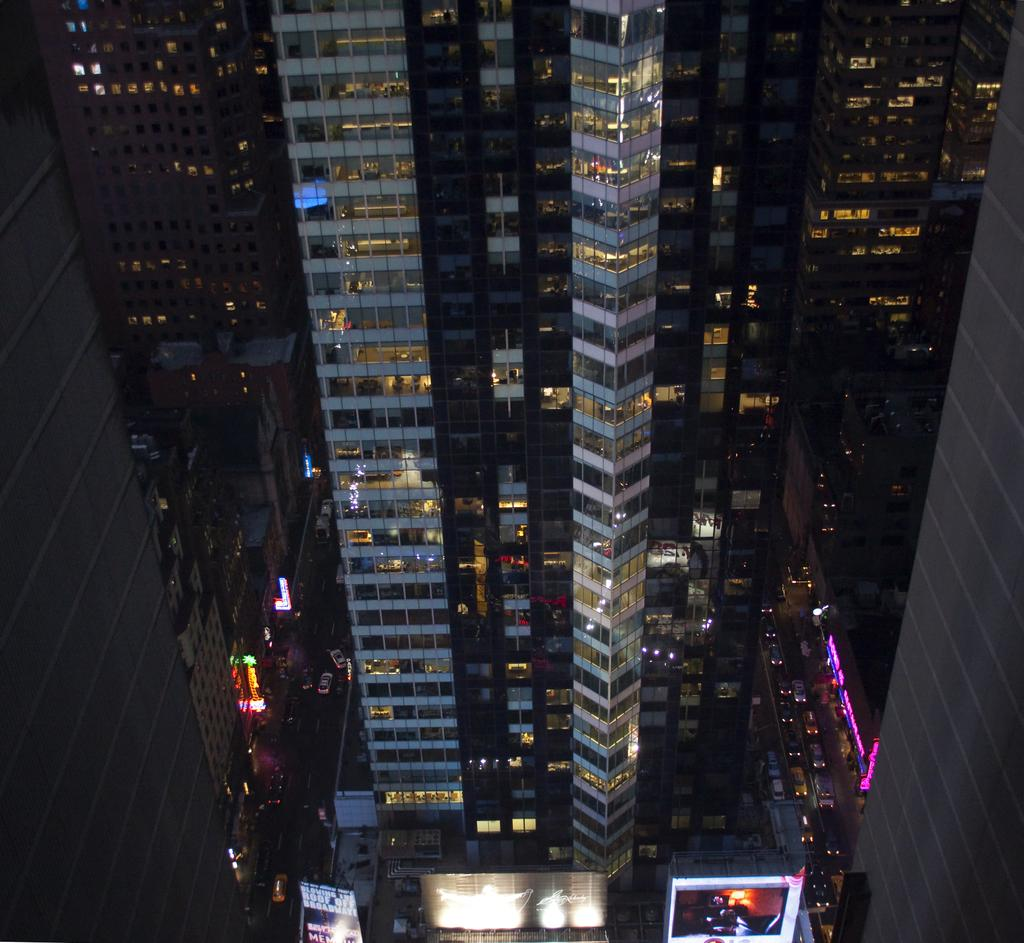What type of structures are present in the image? There are big buildings in the image. What feature can be observed on the buildings? The buildings have lights. Where is the throne located in the image? There is no throne present in the image. What type of cattle can be seen grazing near the buildings? There is no cattle present in the image. 